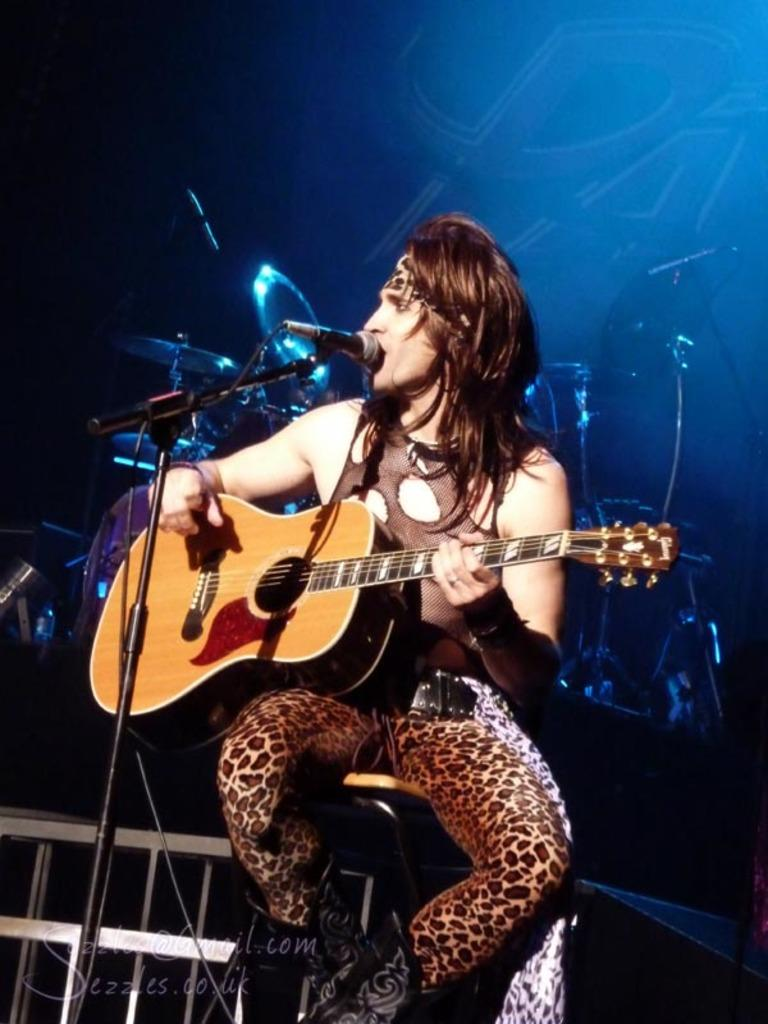Who is the main subject in the image? There is a man in the image. What is the man doing in the image? The man is sitting and playing a guitar. What is the man teaching in the image? There is no indication in the image that the man is teaching anything. 